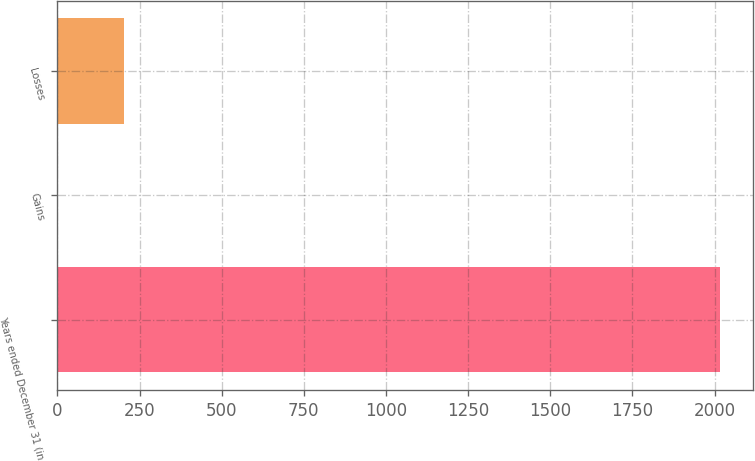Convert chart to OTSL. <chart><loc_0><loc_0><loc_500><loc_500><bar_chart><fcel>Years ended December 31 (in<fcel>Gains<fcel>Losses<nl><fcel>2016<fcel>0.2<fcel>201.78<nl></chart> 